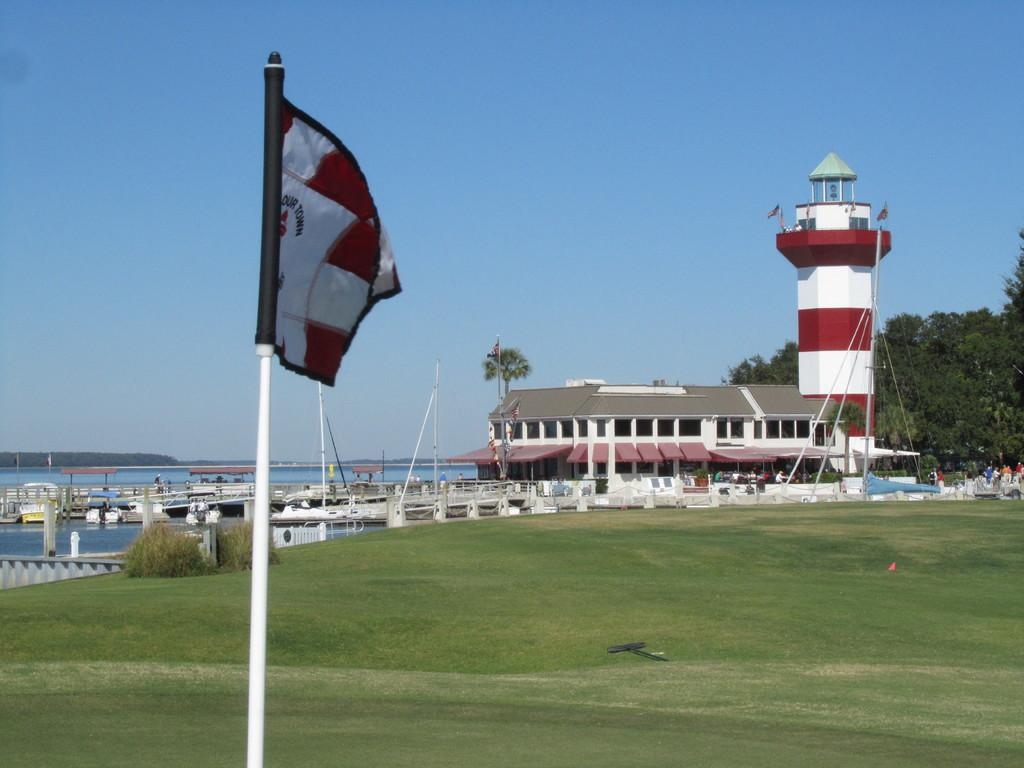What type of location is depicted in the image? There is a harbour town in the image. Where is the flag located in the image? The flag is on the left side of the image. What type of vegetation is on the right side of the image? There are trees on the right side of the image. How many steps does the lace take to reach the top of the flagpole in the image? There is no lace present in the image, and the flagpole is not mentioned, so this question cannot be answered. 